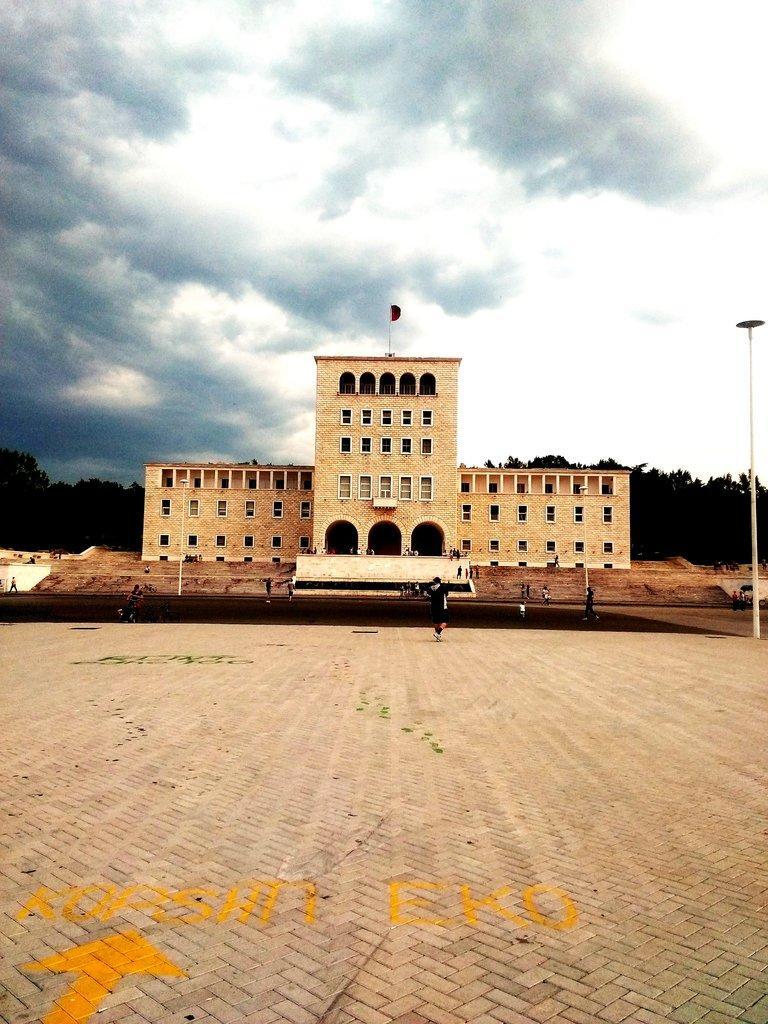In one or two sentences, can you explain what this image depicts? In this image in the middle, there is a building. At the bottom there is a floor. On the right there is a pole. In the middle there are some people. At the top there is flag, sky, clouds and trees. 